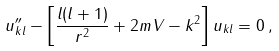Convert formula to latex. <formula><loc_0><loc_0><loc_500><loc_500>u ^ { \prime \prime } _ { k l } - \left [ \frac { l ( l + 1 ) } { r ^ { 2 } } + 2 m V - k ^ { 2 } \right ] u _ { k l } = 0 \, ,</formula> 